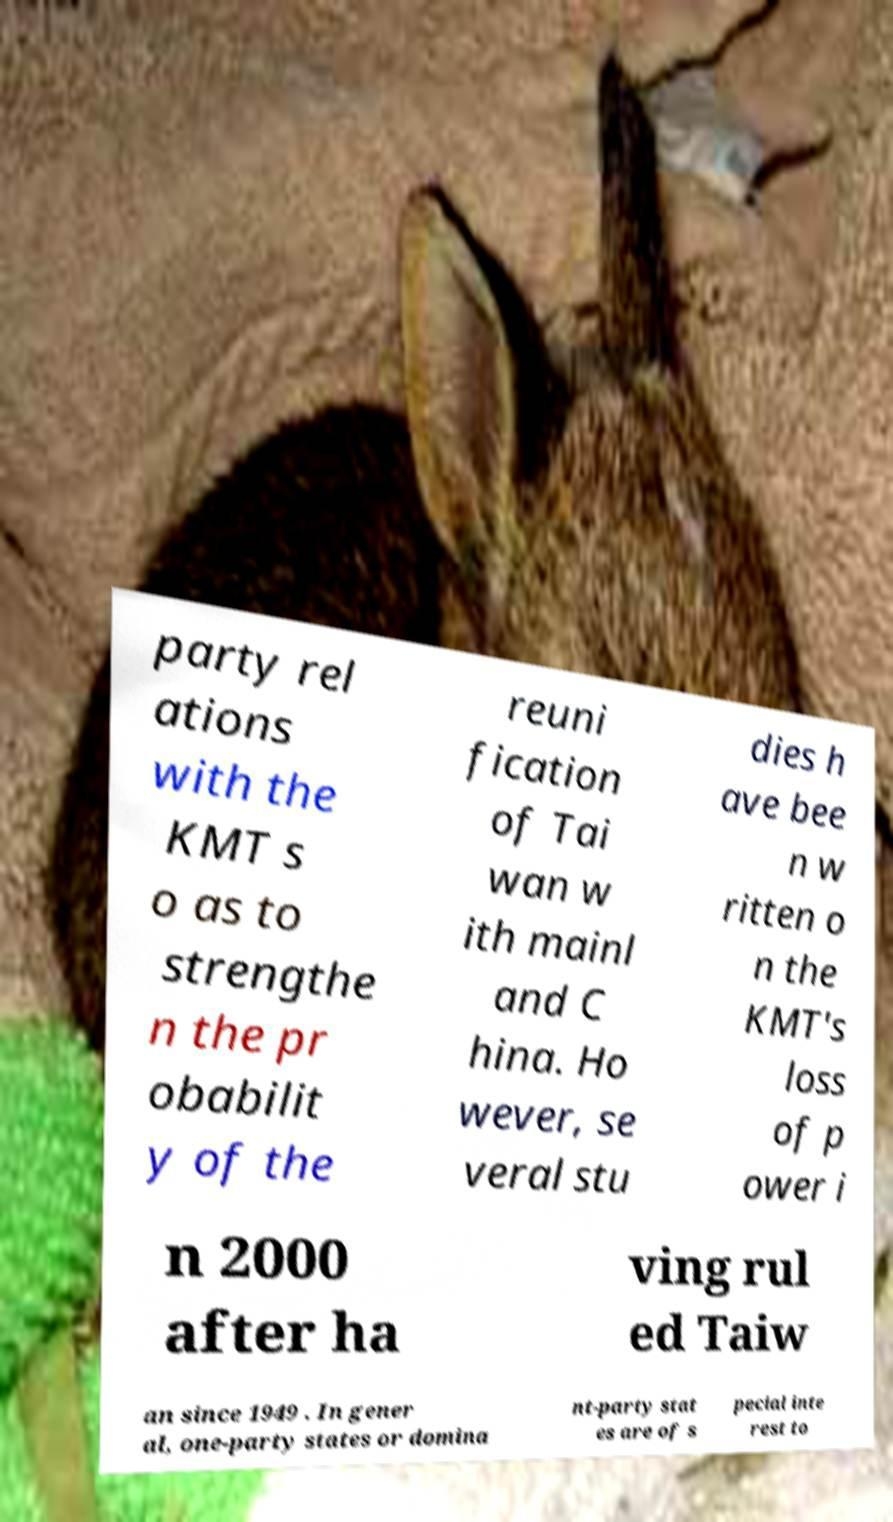Can you accurately transcribe the text from the provided image for me? party rel ations with the KMT s o as to strengthe n the pr obabilit y of the reuni fication of Tai wan w ith mainl and C hina. Ho wever, se veral stu dies h ave bee n w ritten o n the KMT's loss of p ower i n 2000 after ha ving rul ed Taiw an since 1949 . In gener al, one-party states or domina nt-party stat es are of s pecial inte rest to 